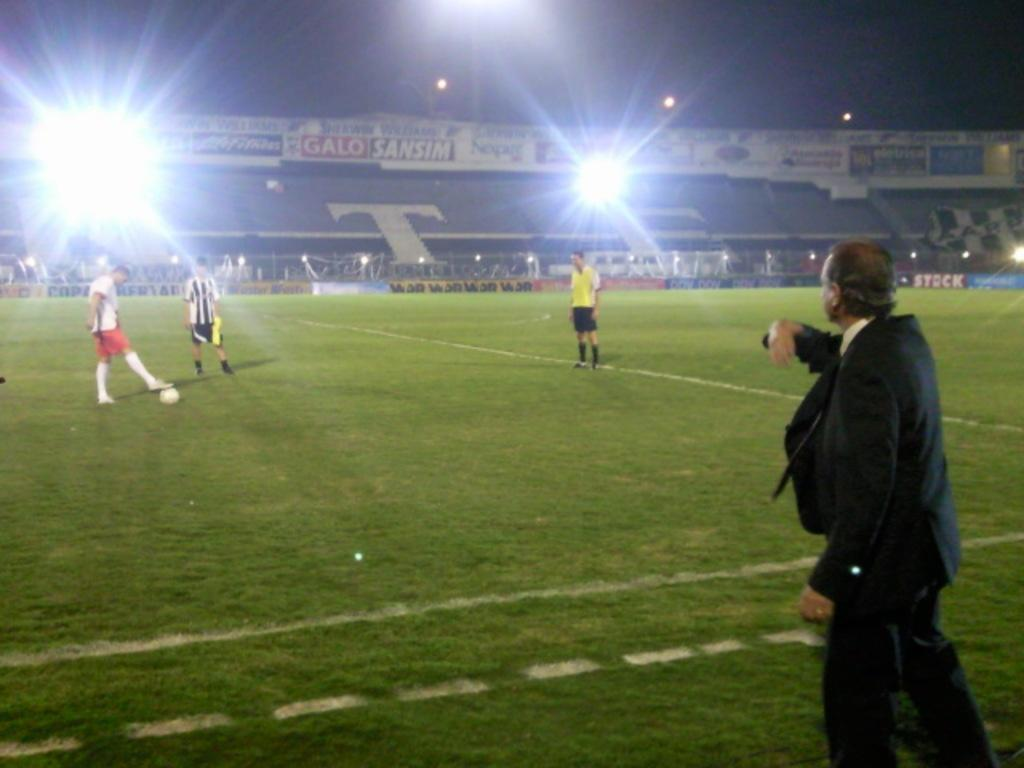<image>
Summarize the visual content of the image. A coach instructs his soccer players from the sideline. 